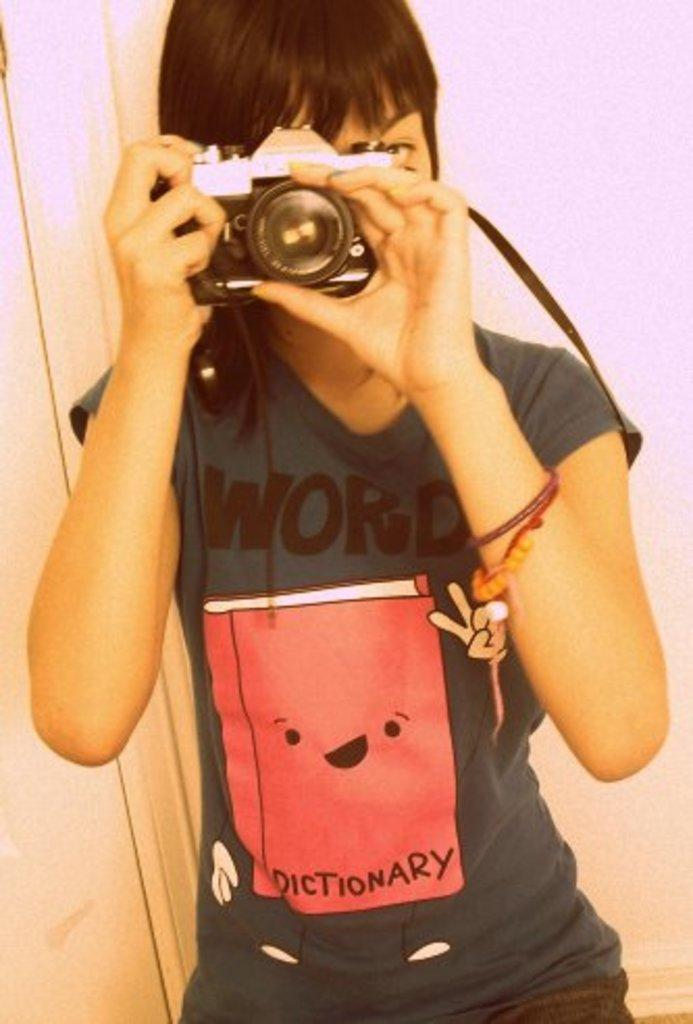What is the main subject of the image? There is a person in the image. What is the person holding in the image? The person is holding a camera. How many snakes are wrapped around the person's neck in the image? There are no snakes present in the image; the person is holding a camera. What type of magic is being performed by the person in the image? There is no indication of magic or any magical activity in the image; the person is simply holding a camera. 